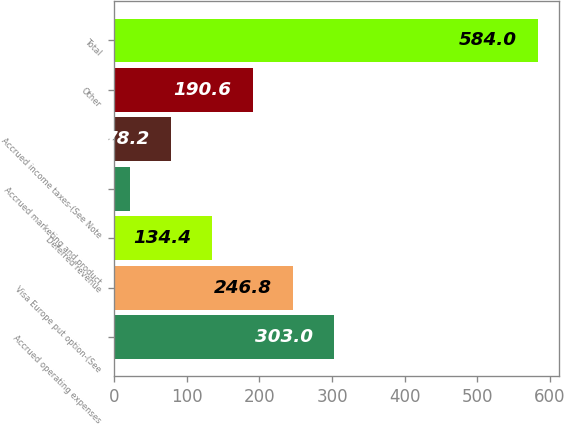Convert chart. <chart><loc_0><loc_0><loc_500><loc_500><bar_chart><fcel>Accrued operating expenses<fcel>Visa Europe put option-(See<fcel>Deferred revenue<fcel>Accrued marketing and product<fcel>Accrued income taxes-(See Note<fcel>Other<fcel>Total<nl><fcel>303<fcel>246.8<fcel>134.4<fcel>22<fcel>78.2<fcel>190.6<fcel>584<nl></chart> 